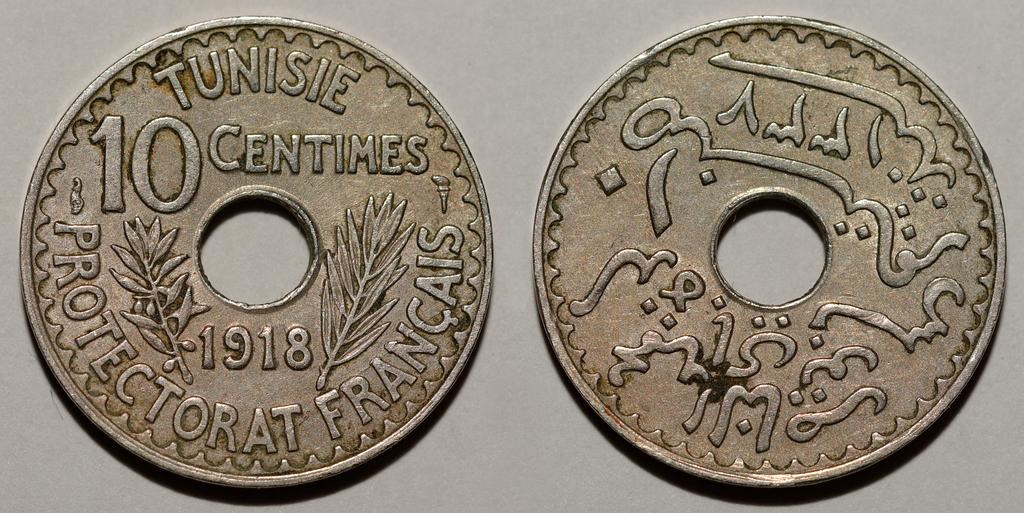<image>
Provide a brief description of the given image. Two Tunisie 10 centimes Protectorat Francais 1918 coins 